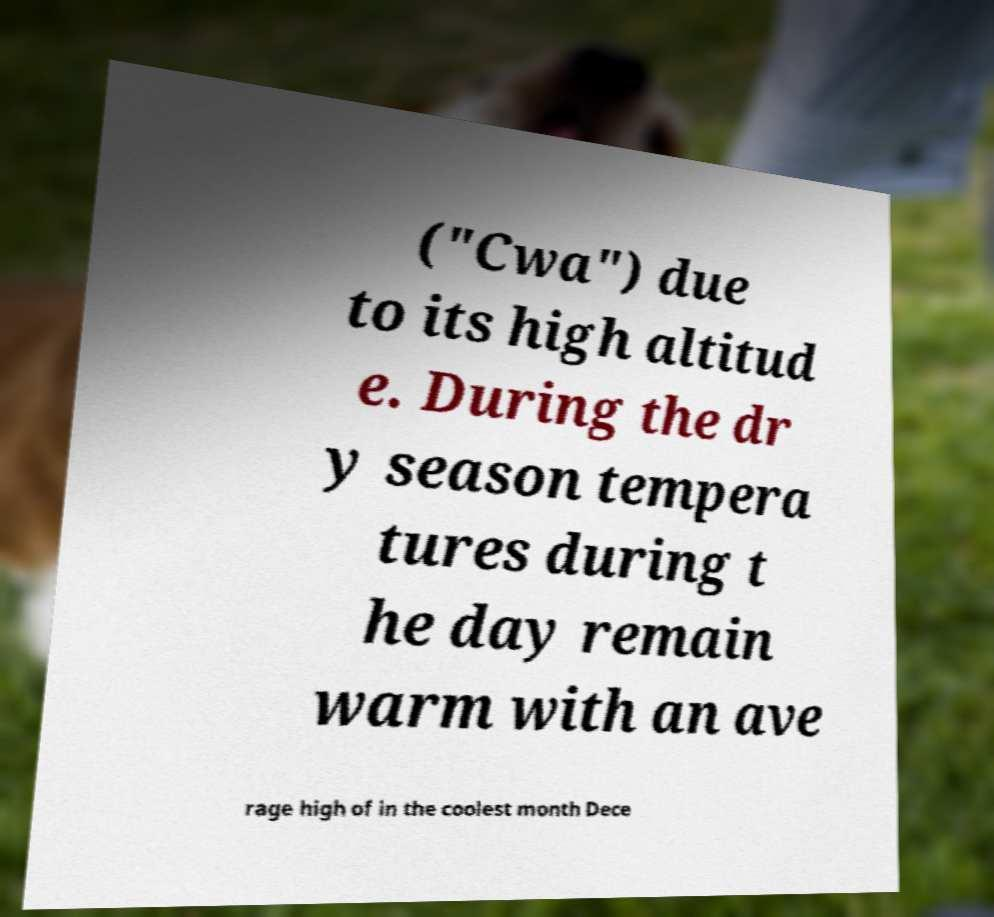Can you accurately transcribe the text from the provided image for me? ("Cwa") due to its high altitud e. During the dr y season tempera tures during t he day remain warm with an ave rage high of in the coolest month Dece 